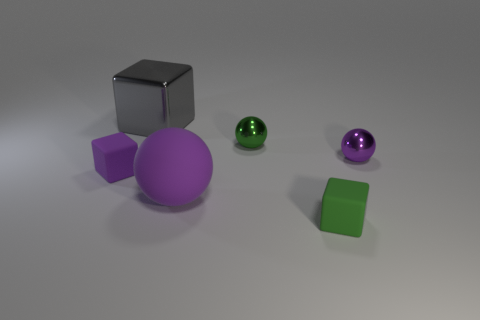What do you think about the arrangement of these objects? The arrangement of the objects appears deliberate, spaced evenly on a neutral gray background. This could suggest an intent to present them in a simple, uncluttered manner, allowing each object to be clearly seen and compared in terms of size, shape, and color. Does the arrangement tell us anything about the size comparison between the objects? Absolutely. By placing the objects at equal distances from one another, it's easier to discern their relative sizes. The larger purple sphere is similar in size to the smaller green sphere, while the two cubes—one silver and one green—also share a similar size, potentially offering a visual sense of comparison between spheres and cubes. 